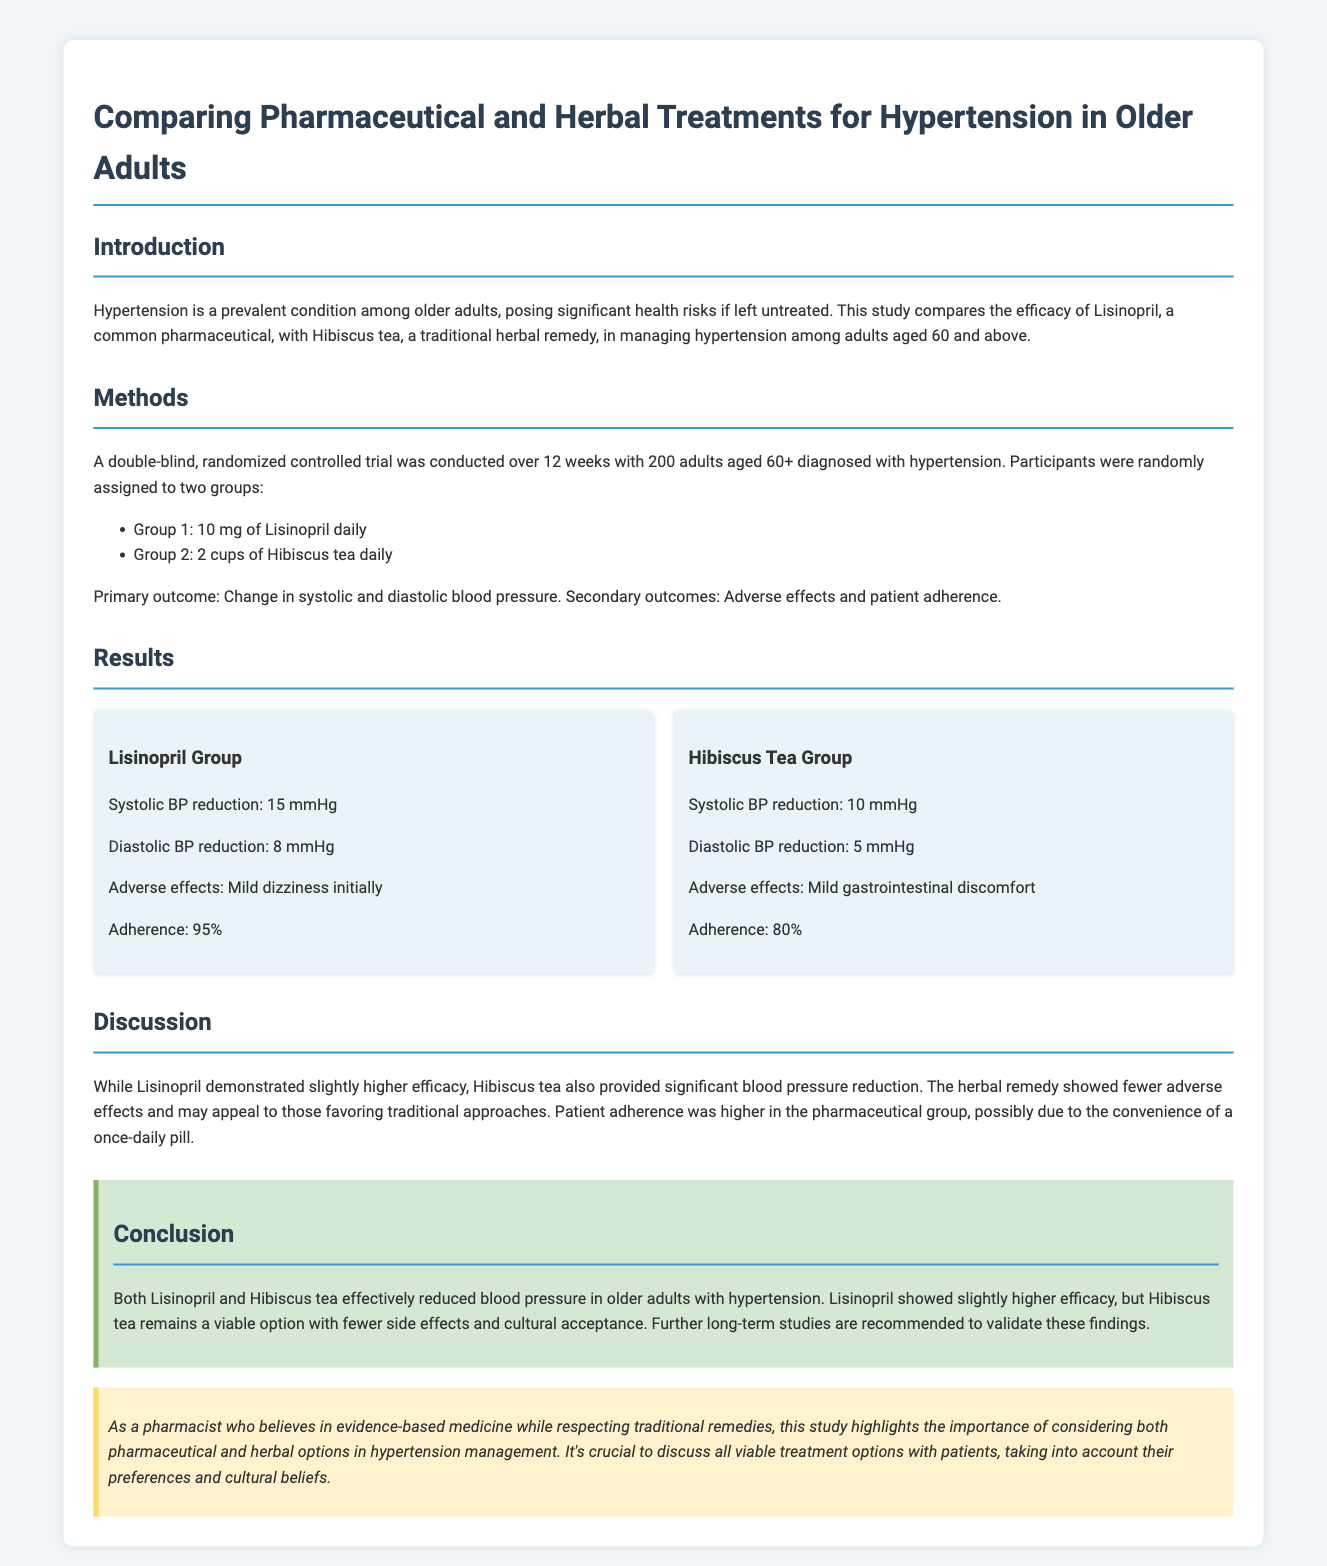What is the primary outcome of the study? The primary outcome is the change in systolic and diastolic blood pressure.
Answer: Change in systolic and diastolic blood pressure What is the reduction in systolic blood pressure for the Lisinopril group? The reduction in systolic blood pressure for the Lisinopril group is specified in the results section.
Answer: 15 mmHg What was the adherence rate in the Hibiscus tea group? The adherence rate for the Hibiscus tea group is mentioned under the results for that group.
Answer: 80% What adverse effect was reported by the Lisinopril group? The specific adverse effect for the Lisinopril group is listed in the results section.
Answer: Mild dizziness Which treatment showed slightly higher efficacy? The document compares the efficacy of both treatments and indicates which one was higher.
Answer: Lisinopril What is the conclusion about Hibiscus tea? The conclusion states the overall effectiveness and perception of Hibiscus tea.
Answer: A viable option with fewer side effects and cultural acceptance How long was the duration of the trial? The trial duration is mentioned in the methodology section of the document.
Answer: 12 weeks What percentage of participants adhered to the Lisinopril treatment? The adherence percentage for the Lisinopril treatment is provided in the results section.
Answer: 95% 